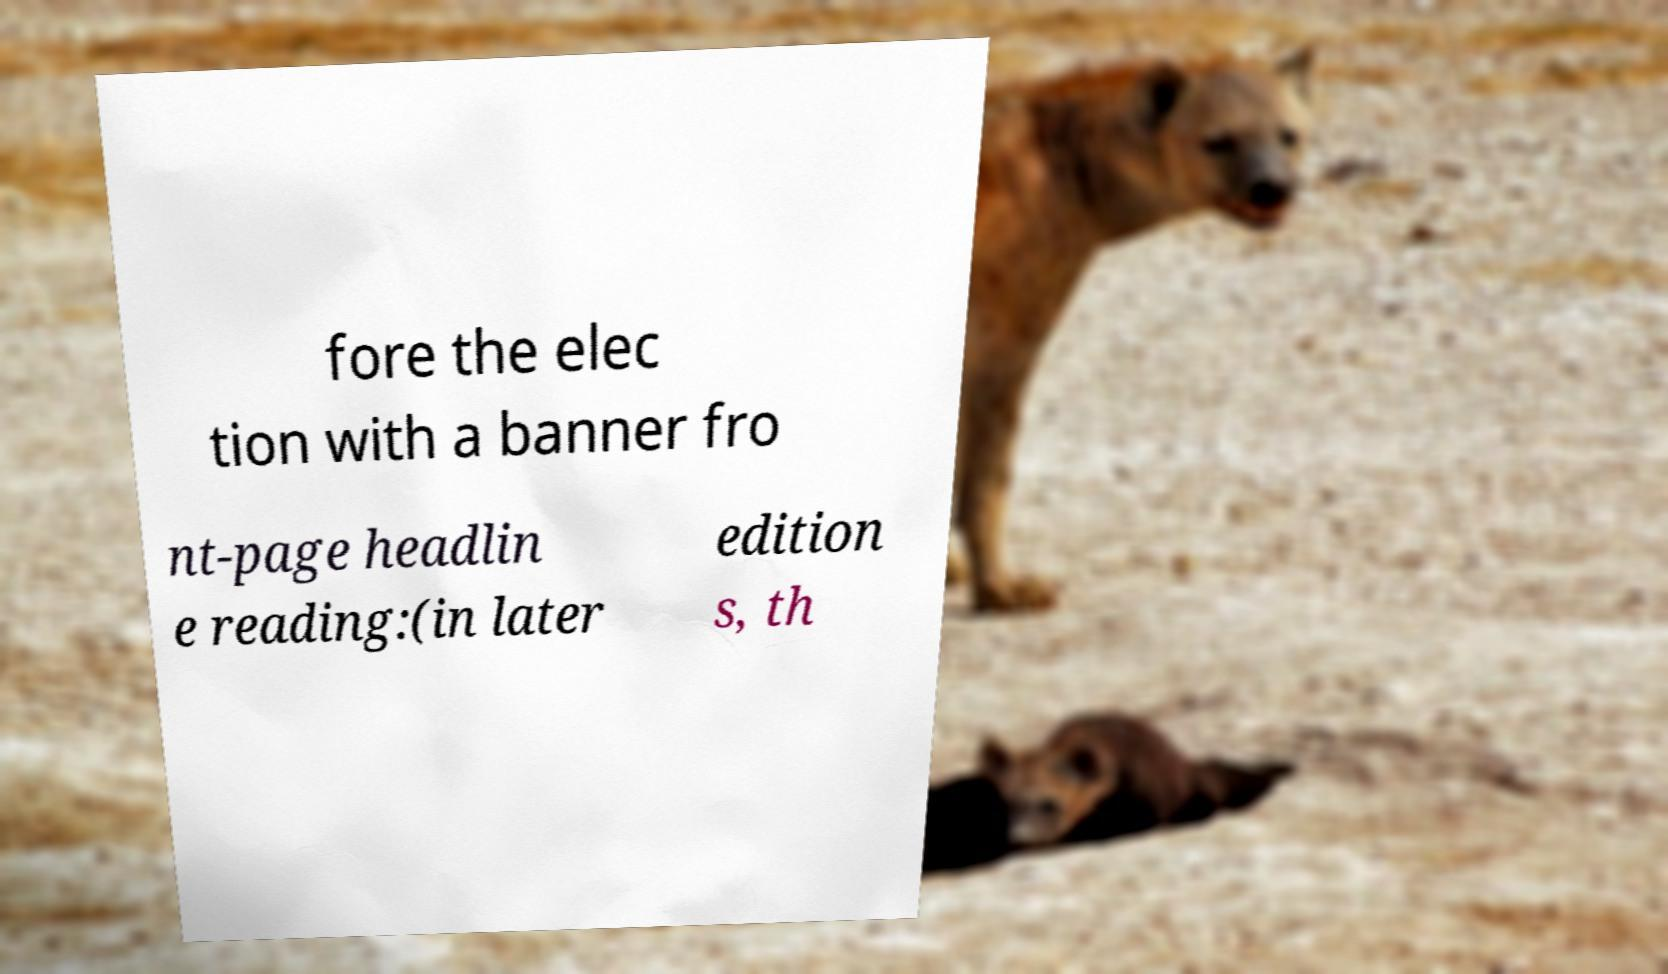Can you read and provide the text displayed in the image?This photo seems to have some interesting text. Can you extract and type it out for me? fore the elec tion with a banner fro nt-page headlin e reading:(in later edition s, th 